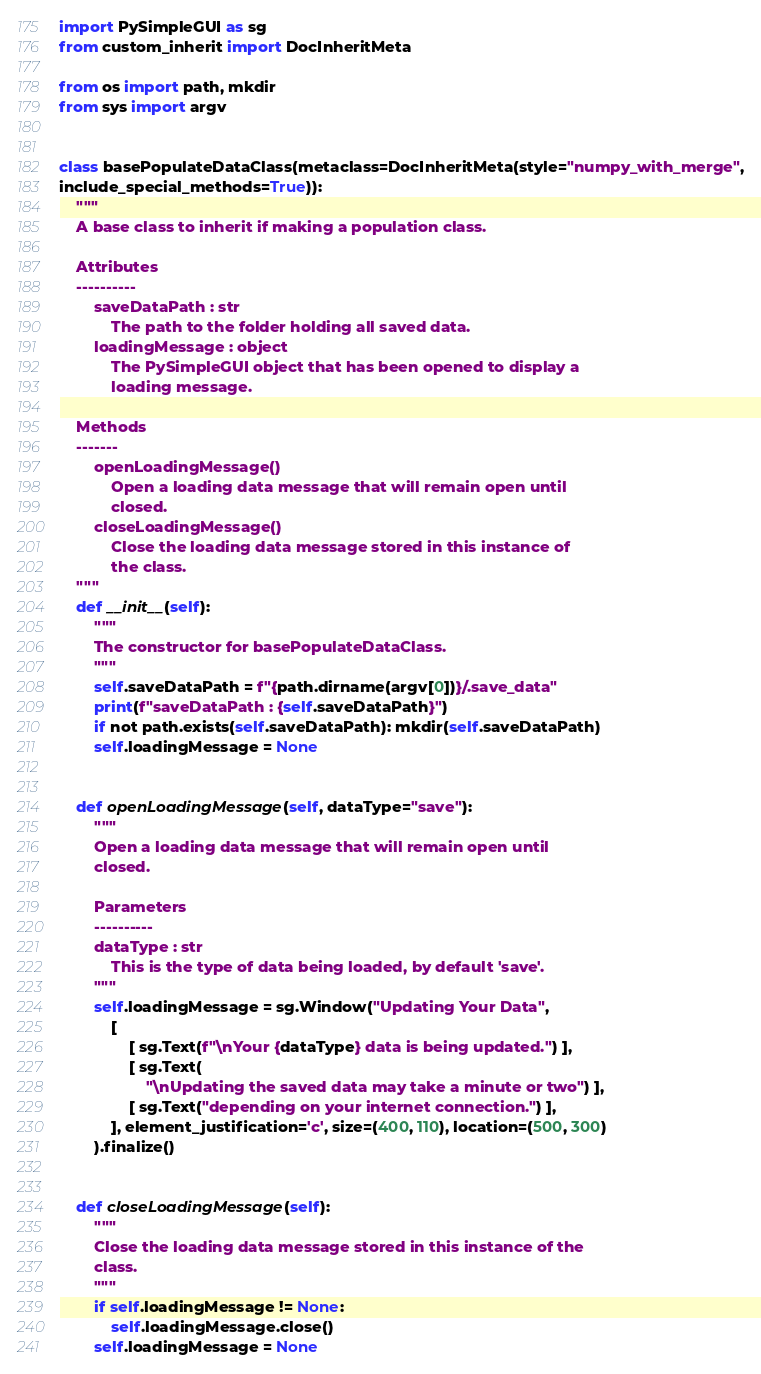Convert code to text. <code><loc_0><loc_0><loc_500><loc_500><_Python_>import PySimpleGUI as sg
from custom_inherit import DocInheritMeta

from os import path, mkdir
from sys import argv


class basePopulateDataClass(metaclass=DocInheritMeta(style="numpy_with_merge",
include_special_methods=True)):
    """
    A base class to inherit if making a population class.

    Attributes
    ----------
        saveDataPath : str
            The path to the folder holding all saved data.
        loadingMessage : object
            The PySimpleGUI object that has been opened to display a
            loading message.

    Methods
    -------
        openLoadingMessage()
            Open a loading data message that will remain open until
            closed.
        closeLoadingMessage()
            Close the loading data message stored in this instance of
            the class.
    """
    def __init__(self):
        """
        The constructor for basePopulateDataClass.
        """
        self.saveDataPath = f"{path.dirname(argv[0])}/.save_data"
        print(f"saveDataPath : {self.saveDataPath}")
        if not path.exists(self.saveDataPath): mkdir(self.saveDataPath)
        self.loadingMessage = None


    def openLoadingMessage(self, dataType="save"):
        """
        Open a loading data message that will remain open until
        closed.

        Parameters
        ----------
        dataType : str
            This is the type of data being loaded, by default 'save'.
        """
        self.loadingMessage = sg.Window("Updating Your Data",
            [
                [ sg.Text(f"\nYour {dataType} data is being updated.") ],
                [ sg.Text(
                    "\nUpdating the saved data may take a minute or two") ],
                [ sg.Text("depending on your internet connection.") ],
            ], element_justification='c', size=(400, 110), location=(500, 300)
        ).finalize()


    def closeLoadingMessage(self):
        """
        Close the loading data message stored in this instance of the
        class.
        """
        if self.loadingMessage != None:
            self.loadingMessage.close()
        self.loadingMessage = None
</code> 